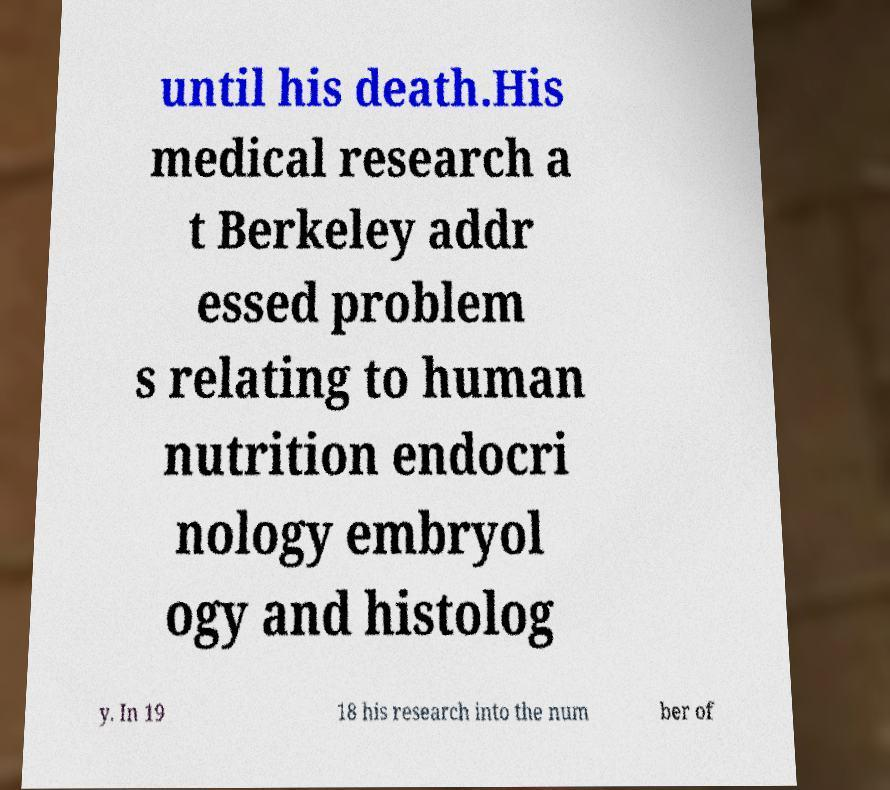Can you accurately transcribe the text from the provided image for me? until his death.His medical research a t Berkeley addr essed problem s relating to human nutrition endocri nology embryol ogy and histolog y. In 19 18 his research into the num ber of 